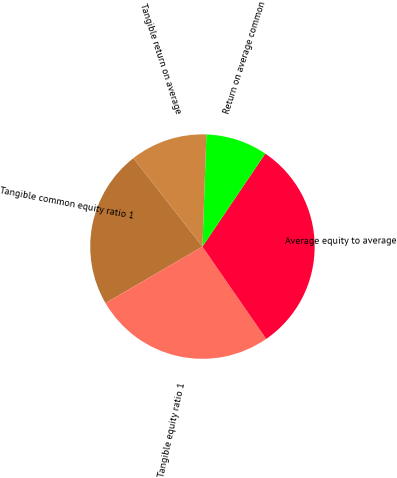Convert chart to OTSL. <chart><loc_0><loc_0><loc_500><loc_500><pie_chart><fcel>Tangible common equity ratio 1<fcel>Tangible equity ratio 1<fcel>Average equity to average<fcel>Return on average common<fcel>Tangible return on average<nl><fcel>22.85%<fcel>26.22%<fcel>30.92%<fcel>8.9%<fcel>11.11%<nl></chart> 